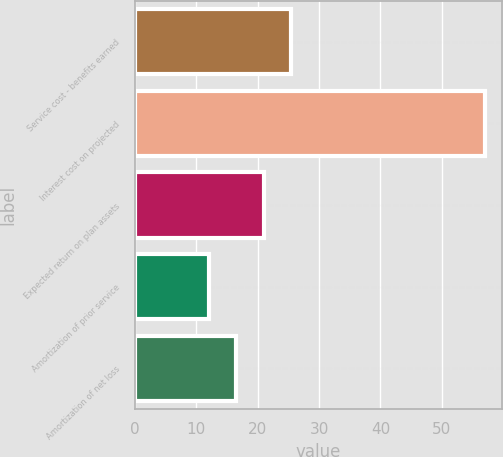<chart> <loc_0><loc_0><loc_500><loc_500><bar_chart><fcel>Service cost - benefits earned<fcel>Interest cost on projected<fcel>Expected return on plan assets<fcel>Amortization of prior service<fcel>Amortization of net loss<nl><fcel>25.5<fcel>57<fcel>21<fcel>12<fcel>16.5<nl></chart> 